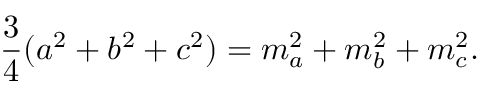<formula> <loc_0><loc_0><loc_500><loc_500>{ \frac { 3 } { 4 } } ( a ^ { 2 } + b ^ { 2 } + c ^ { 2 } ) = m _ { a } ^ { 2 } + m _ { b } ^ { 2 } + m _ { c } ^ { 2 } .</formula> 